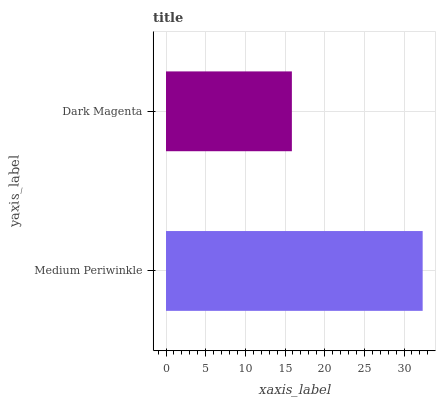Is Dark Magenta the minimum?
Answer yes or no. Yes. Is Medium Periwinkle the maximum?
Answer yes or no. Yes. Is Dark Magenta the maximum?
Answer yes or no. No. Is Medium Periwinkle greater than Dark Magenta?
Answer yes or no. Yes. Is Dark Magenta less than Medium Periwinkle?
Answer yes or no. Yes. Is Dark Magenta greater than Medium Periwinkle?
Answer yes or no. No. Is Medium Periwinkle less than Dark Magenta?
Answer yes or no. No. Is Medium Periwinkle the high median?
Answer yes or no. Yes. Is Dark Magenta the low median?
Answer yes or no. Yes. Is Dark Magenta the high median?
Answer yes or no. No. Is Medium Periwinkle the low median?
Answer yes or no. No. 